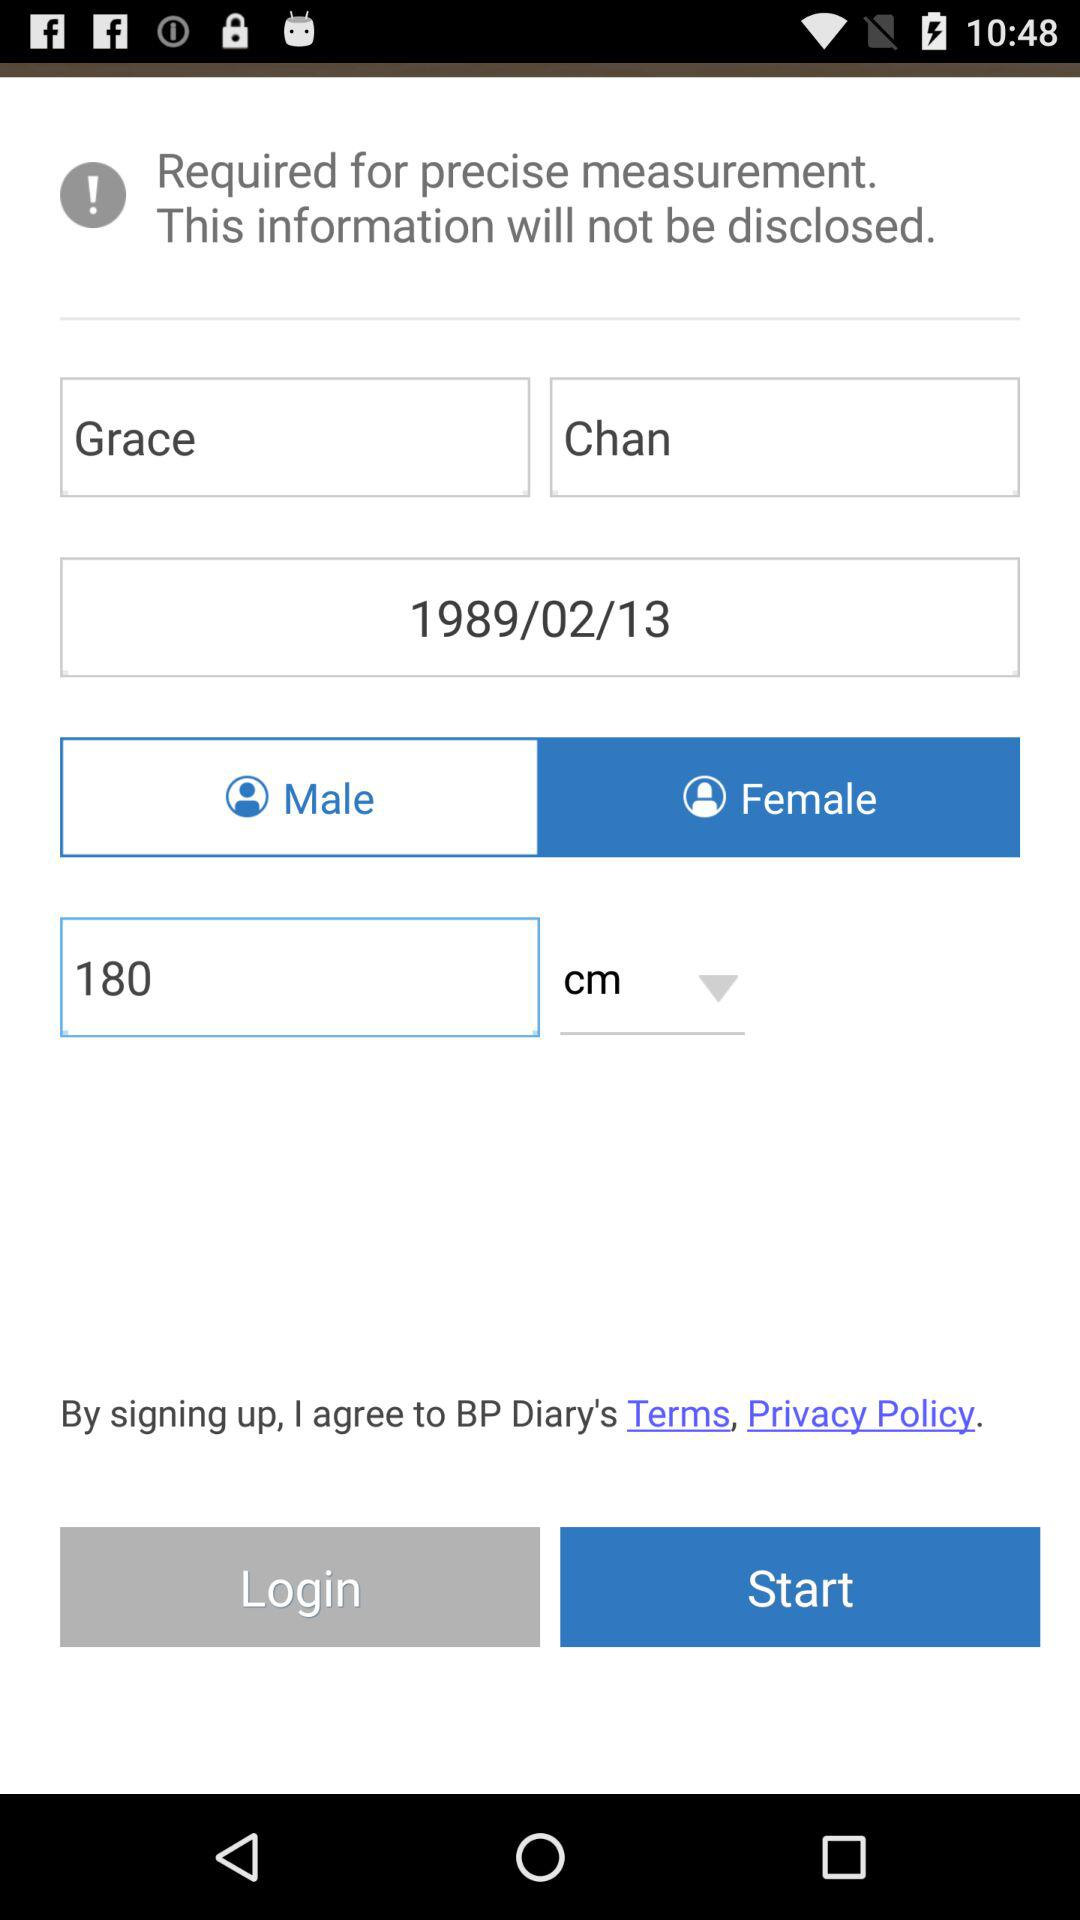What is the name? The name is Grace Chan. 